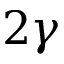<formula> <loc_0><loc_0><loc_500><loc_500>2 \gamma</formula> 